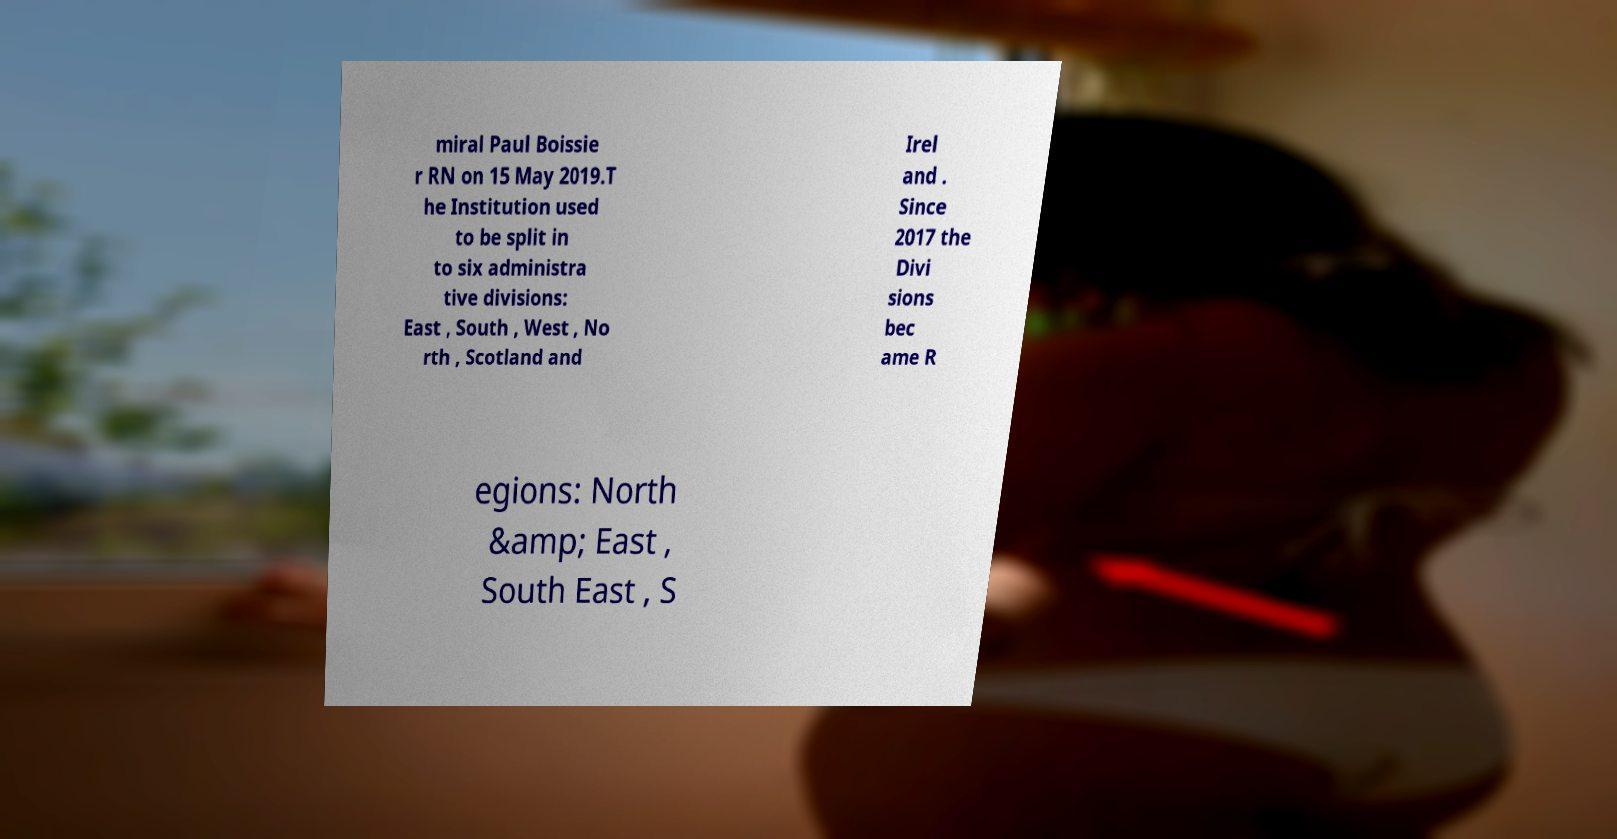There's text embedded in this image that I need extracted. Can you transcribe it verbatim? miral Paul Boissie r RN on 15 May 2019.T he Institution used to be split in to six administra tive divisions: East , South , West , No rth , Scotland and Irel and . Since 2017 the Divi sions bec ame R egions: North &amp; East , South East , S 